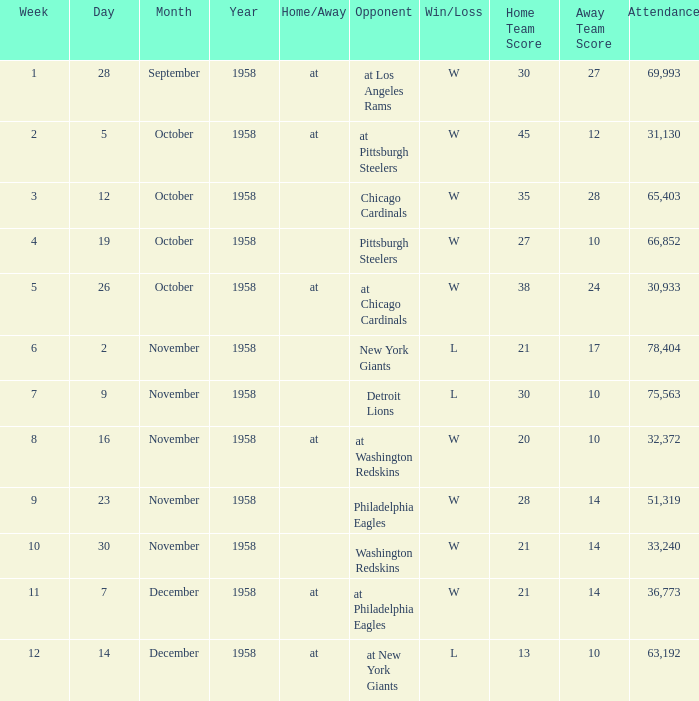What day experienced an attendance of over 51,319 during the fourth week? October 19, 1958. 